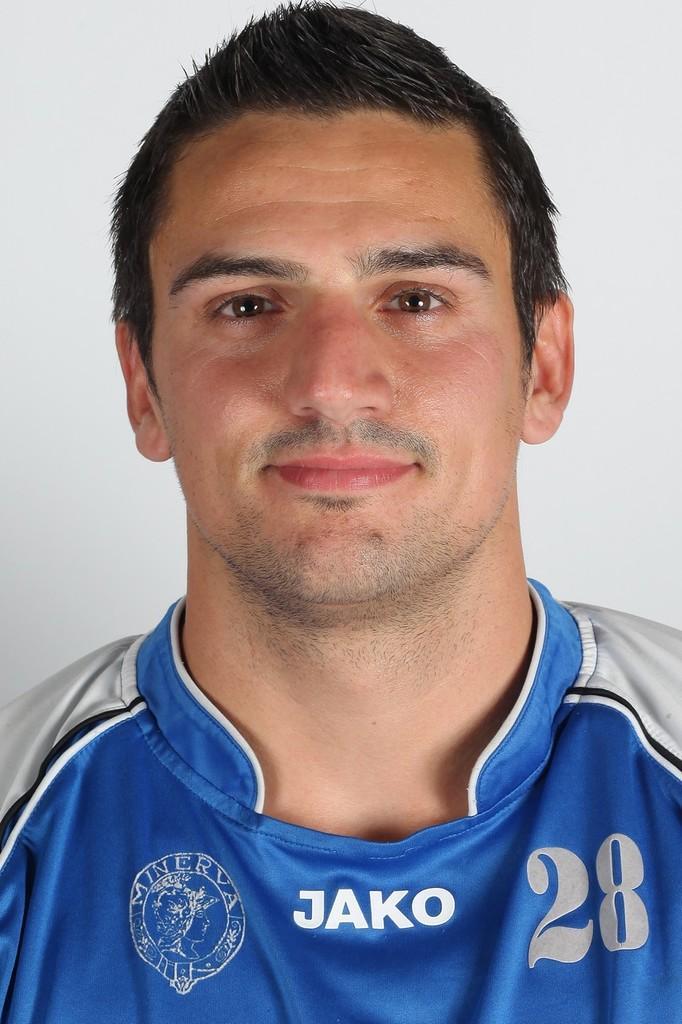Could you give a brief overview of what you see in this image? This image consists of a man wearing a blue color jersey. In the background, we can see a wall in white color. 